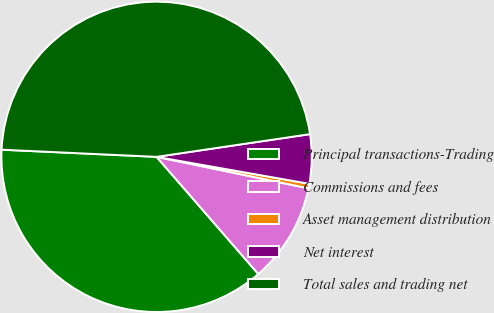Convert chart to OTSL. <chart><loc_0><loc_0><loc_500><loc_500><pie_chart><fcel>Principal transactions-Trading<fcel>Commissions and fees<fcel>Asset management distribution<fcel>Net interest<fcel>Total sales and trading net<nl><fcel>37.12%<fcel>10.37%<fcel>0.47%<fcel>5.12%<fcel>46.93%<nl></chart> 